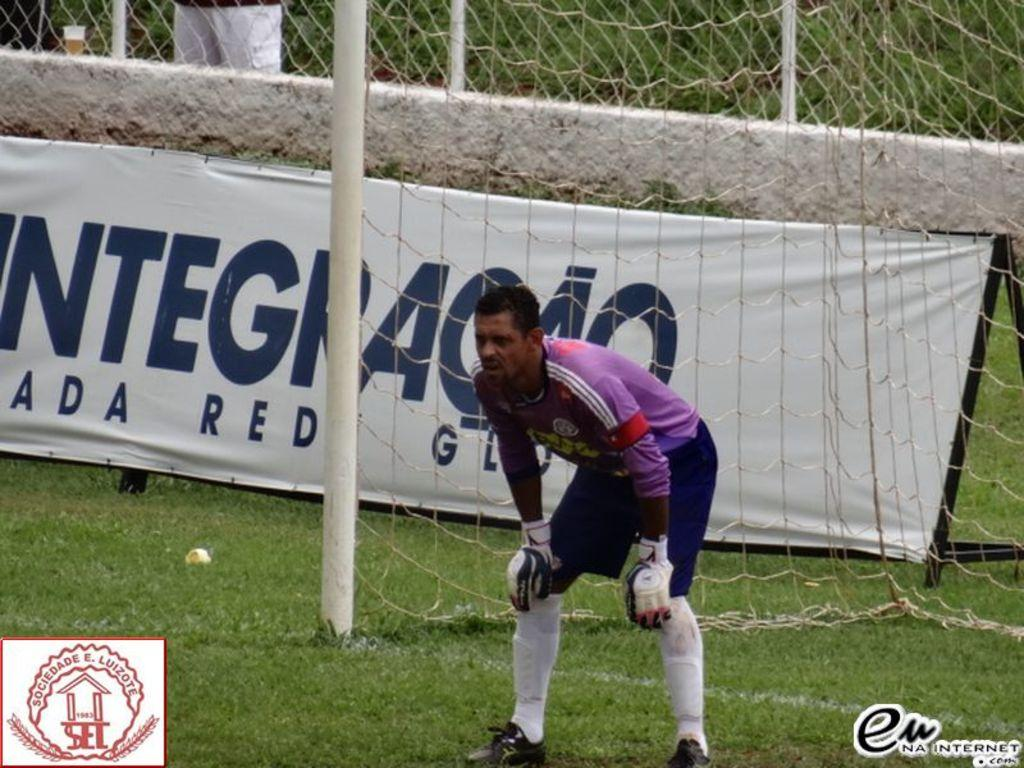What is the man in the image doing? The man is standing and bending in the image. What is the surface beneath the man? The man is standing on a grass surface. What object is visible behind the man? There is a net with a pole in the image, and it is behind the man. Can you describe any additional elements in the background? A: There is a banner near the wall in the image. How does the man increase the water pressure in the image? There is no indication of water or water pressure in the image; the man is simply standing and bending. 